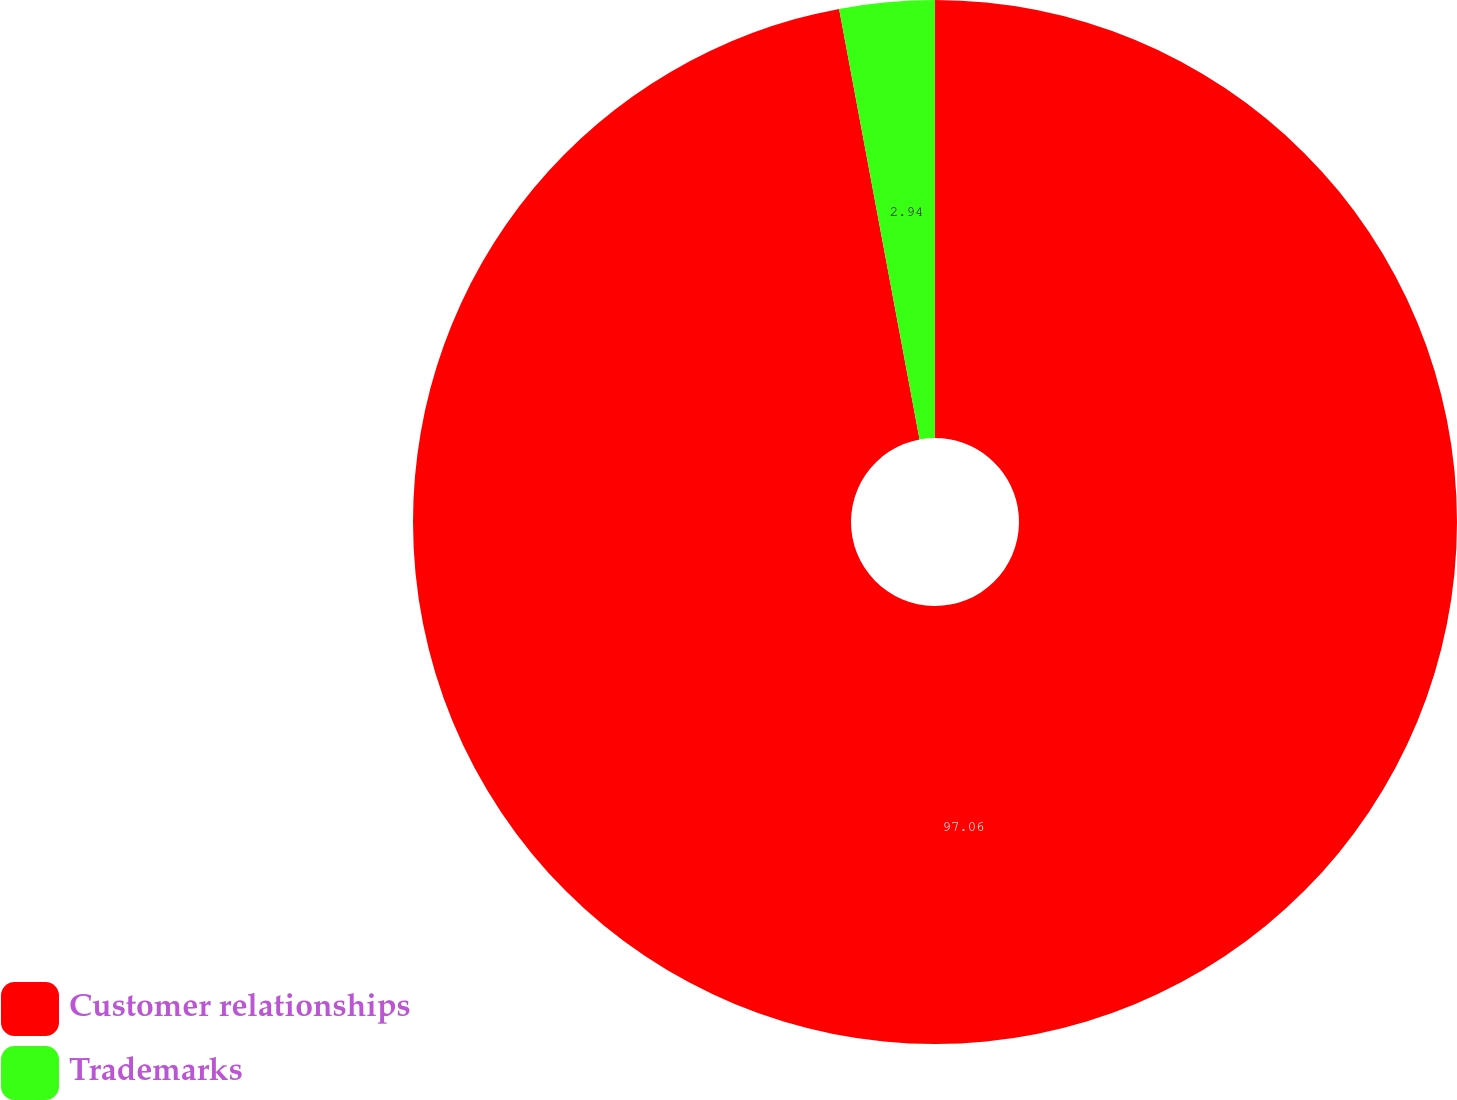Convert chart to OTSL. <chart><loc_0><loc_0><loc_500><loc_500><pie_chart><fcel>Customer relationships<fcel>Trademarks<nl><fcel>97.06%<fcel>2.94%<nl></chart> 